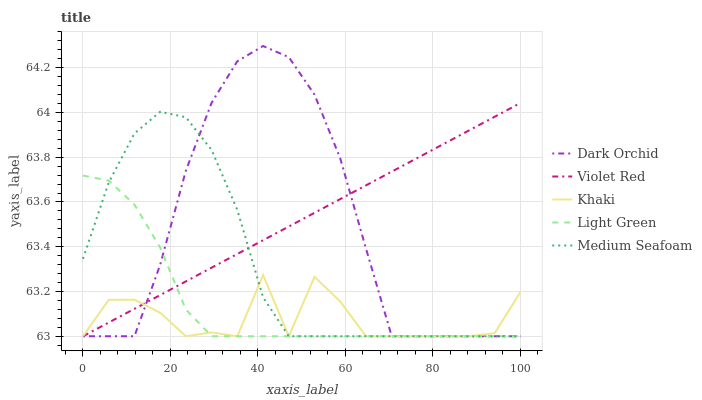Does Khaki have the minimum area under the curve?
Answer yes or no. Yes. Does Violet Red have the maximum area under the curve?
Answer yes or no. Yes. Does Light Green have the minimum area under the curve?
Answer yes or no. No. Does Light Green have the maximum area under the curve?
Answer yes or no. No. Is Violet Red the smoothest?
Answer yes or no. Yes. Is Khaki the roughest?
Answer yes or no. Yes. Is Light Green the smoothest?
Answer yes or no. No. Is Light Green the roughest?
Answer yes or no. No. Does Violet Red have the lowest value?
Answer yes or no. Yes. Does Dark Orchid have the highest value?
Answer yes or no. Yes. Does Light Green have the highest value?
Answer yes or no. No. Does Dark Orchid intersect Light Green?
Answer yes or no. Yes. Is Dark Orchid less than Light Green?
Answer yes or no. No. Is Dark Orchid greater than Light Green?
Answer yes or no. No. 